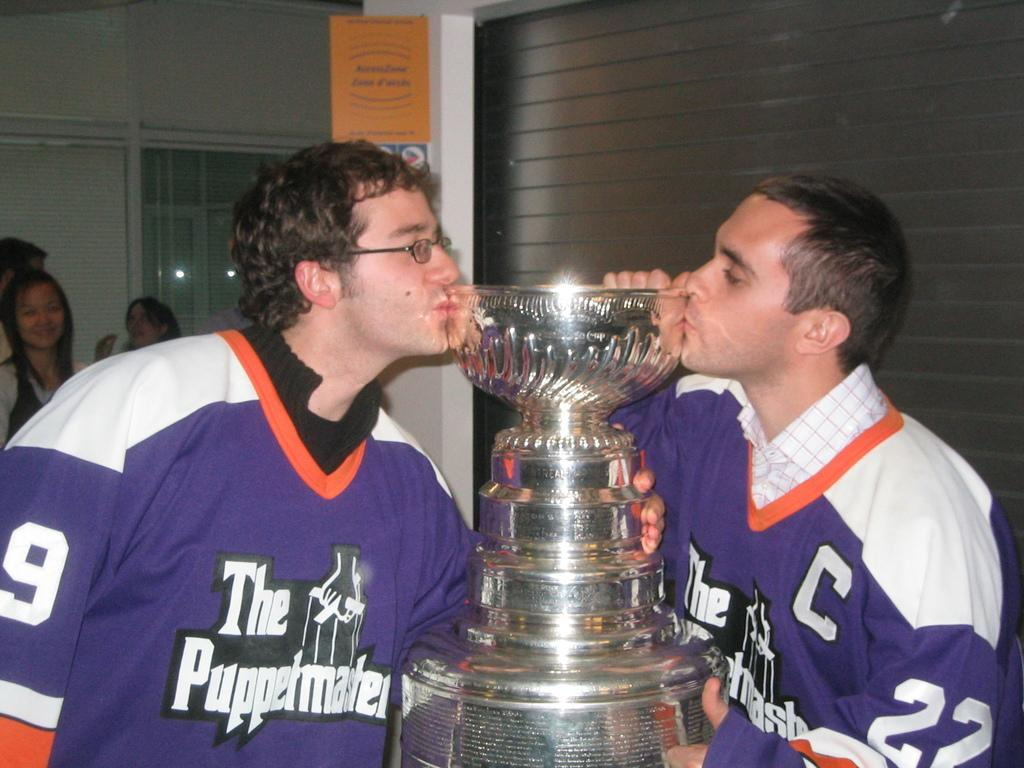<image>
Summarize the visual content of the image. The Puppetmasters are kissing the trophy from each side. 